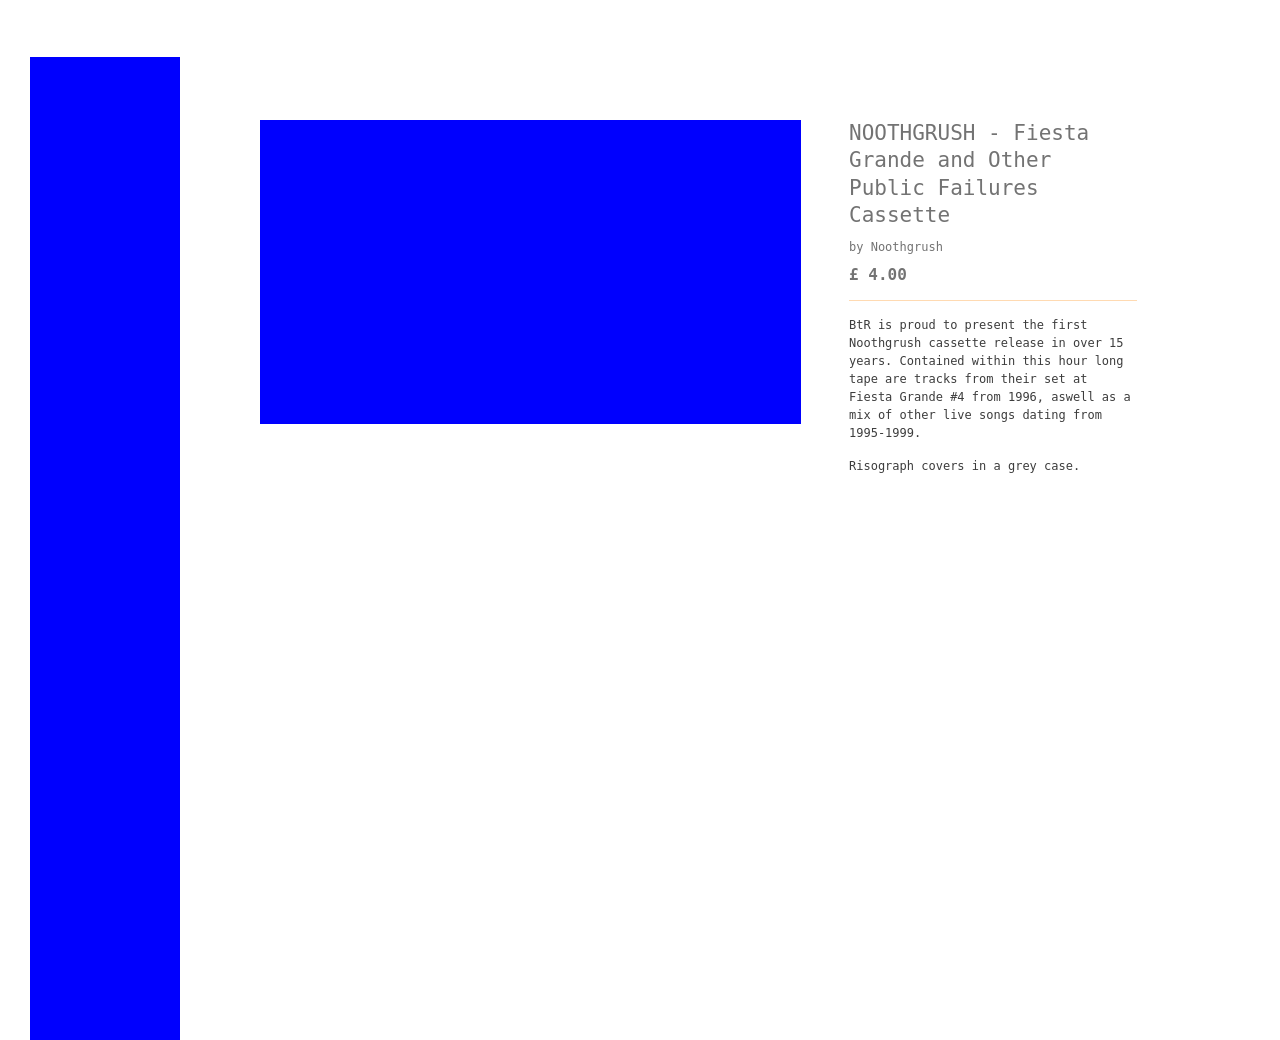Could you detail the process for assembling this website using HTML? Assembling a website using HTML involves several key steps. First, define the structure of your pages using HTML elements like <header>, <nav>, <main>, and <footer>. Use <div> elements to create sections and <h1> to <h6> for headings. Include <p> tags for paragraphs and anchor tags <a> for hyperlinks. Style your website using CSS to add colors, layouts, and fonts, which you attach to your HTML using a <link> or <style> tag. Add interactivity with JavaScript by linking .js files or embedding scripts directly. Finally, test your website across different browsers and devices to ensure compatibility and functionality. Be sure to also consider SEO best practices by properly using meta tags and structured data. 